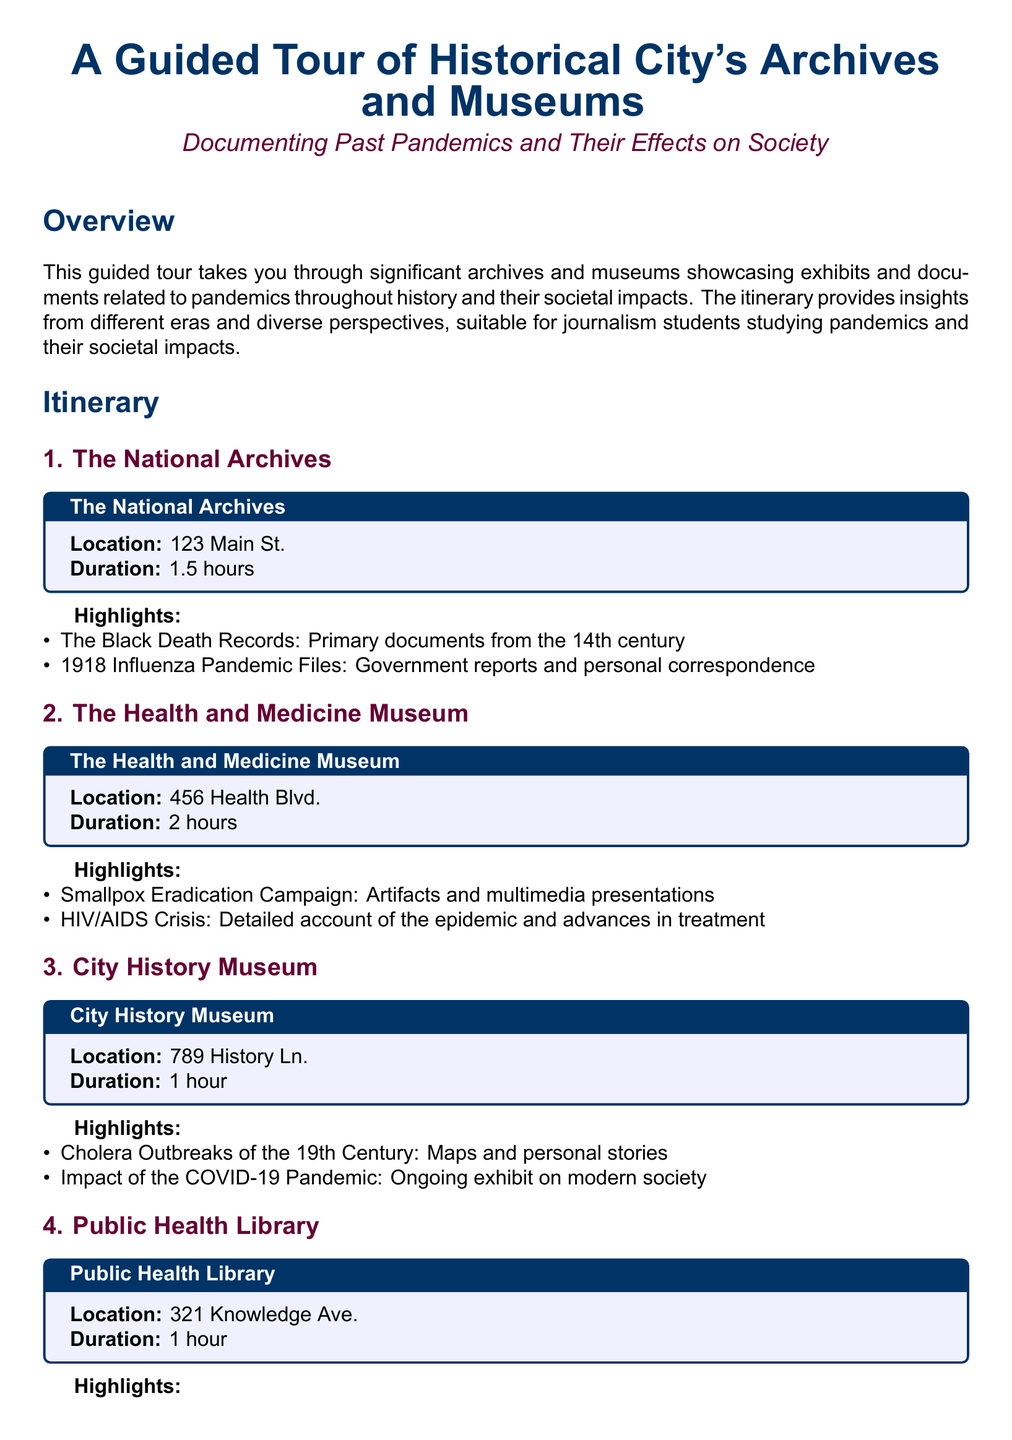What is the location of The National Archives? The document provides the address for The National Archives as 123 Main St.
Answer: 123 Main St How long is the visit to the Health and Medicine Museum? The itinerary states that the visit to the Health and Medicine Museum lasts for 2 hours.
Answer: 2 hours What pandemic is detailed in the HIV/AIDS Crisis exhibit? The document specifies that the exhibit at the Health and Medicine Museum is about the HIV/AIDS Crisis.
Answer: HIV/AIDS Crisis Which century do the Cholera Outbreaks covered in the City History Museum belong to? The itinerary mentions that the Cholera Outbreaks of the City History Museum are from the 19th Century.
Answer: 19th Century What type of literature can be found in the Public Health Library? The document indicates that the Public Health Library has a special collection of Pandemic Literature.
Answer: Pandemic Literature What is one highlight from The National Archives? The highlights listed include The Black Death Records as one significant aspect from The National Archives.
Answer: The Black Death Records What are the two main topics covered in the City History Museum? The itinerary lists Cholera Outbreaks of the 19th Century and Impact of the COVID-19 Pandemic as the two main topics.
Answer: Cholera Outbreaks of the 19th Century and Impact of the COVID-19 Pandemic How many hours do the archives and museums take to visit in total? To find the total duration, add the visit lengths: 1.5 hours + 2 hours + 1 hour + 1 hour, resulting in 5.5 hours total.
Answer: 5.5 hours Which archive houses a collection of epidemiological studies? The document identifies the Public Health Library as the location for Epidemiological Studies.
Answer: Public Health Library 